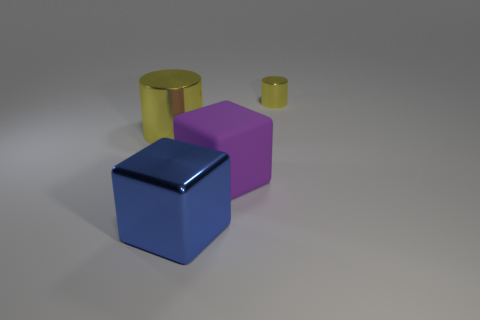Add 3 yellow shiny things. How many objects exist? 7 Subtract all gray blocks. How many gray cylinders are left? 0 Subtract 0 red spheres. How many objects are left? 4 Subtract 1 blocks. How many blocks are left? 1 Subtract all blue cylinders. Subtract all brown balls. How many cylinders are left? 2 Subtract all tiny yellow matte cubes. Subtract all shiny cylinders. How many objects are left? 2 Add 3 small yellow objects. How many small yellow objects are left? 4 Add 2 large yellow metallic things. How many large yellow metallic things exist? 3 